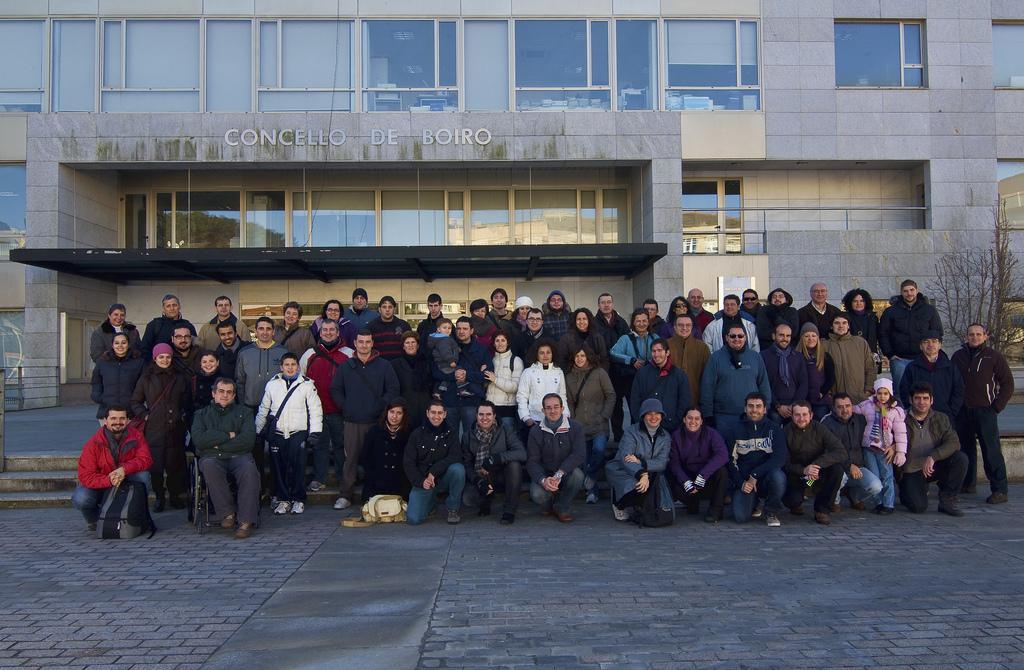Please provide a concise description of this image. There is an organisation building,in front of the building a group of people are posing for the photo and most of them are wearing jackets and in the right side of the people there is a dry tree. 